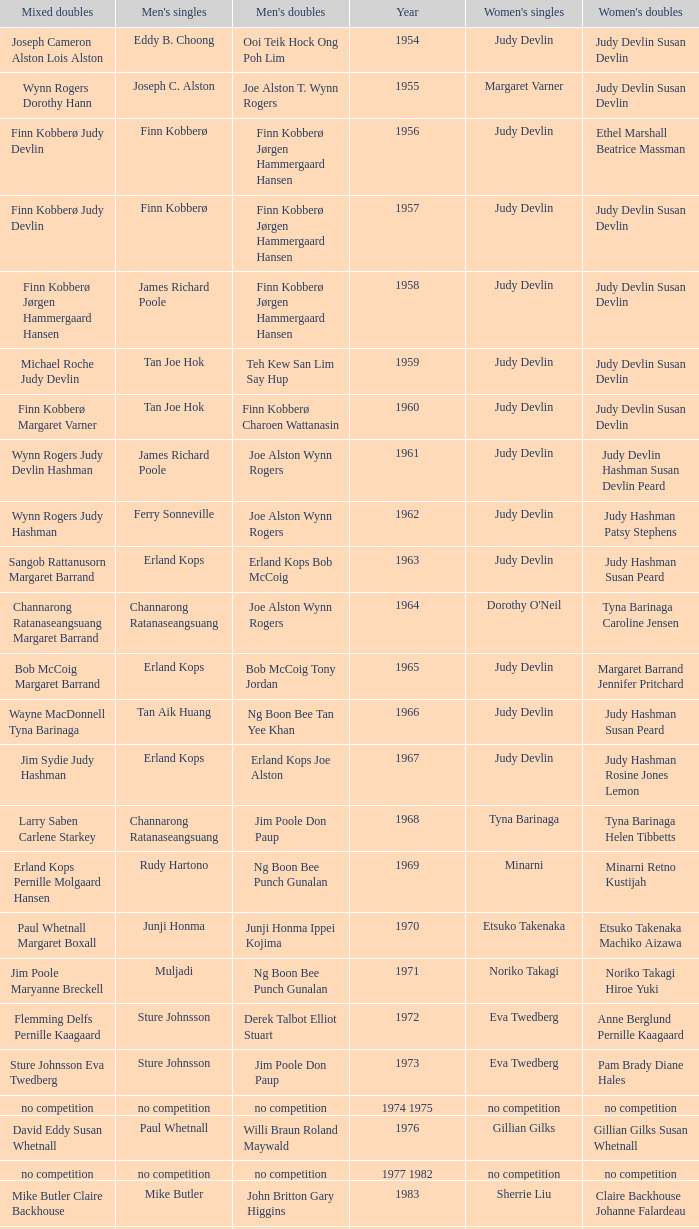Who were the men's doubles champions when the men's singles champion was muljadi? Ng Boon Bee Punch Gunalan. 